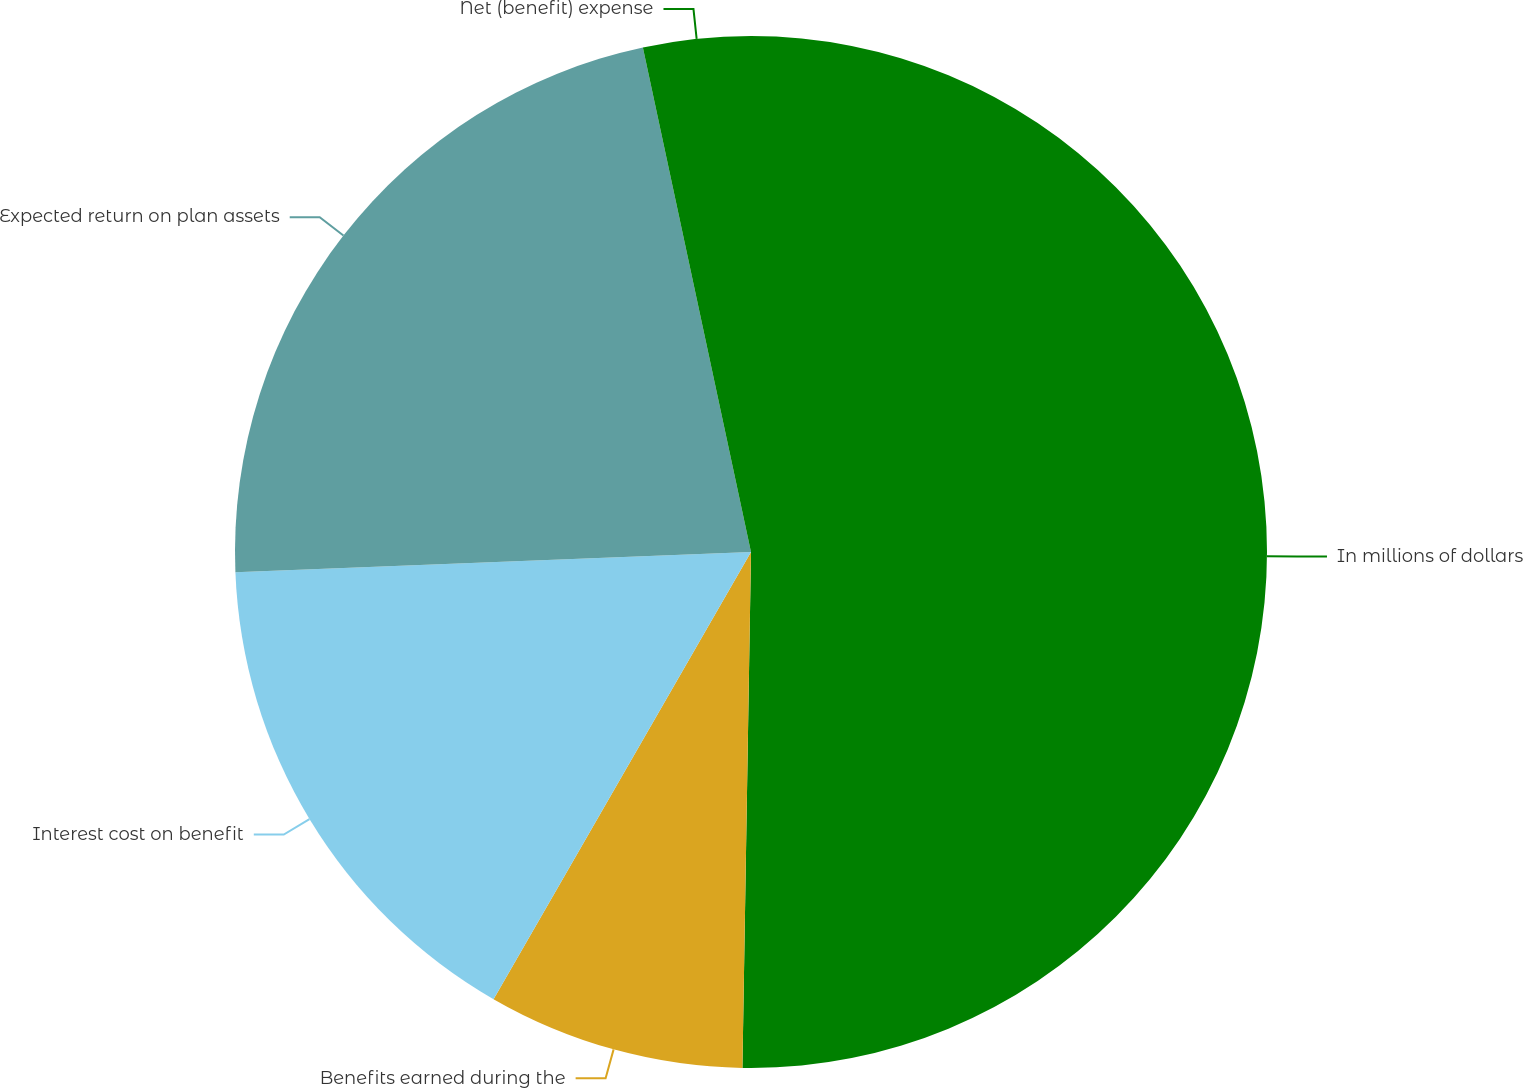<chart> <loc_0><loc_0><loc_500><loc_500><pie_chart><fcel>In millions of dollars<fcel>Benefits earned during the<fcel>Interest cost on benefit<fcel>Expected return on plan assets<fcel>Net (benefit) expense<nl><fcel>50.27%<fcel>8.05%<fcel>16.06%<fcel>22.27%<fcel>3.36%<nl></chart> 